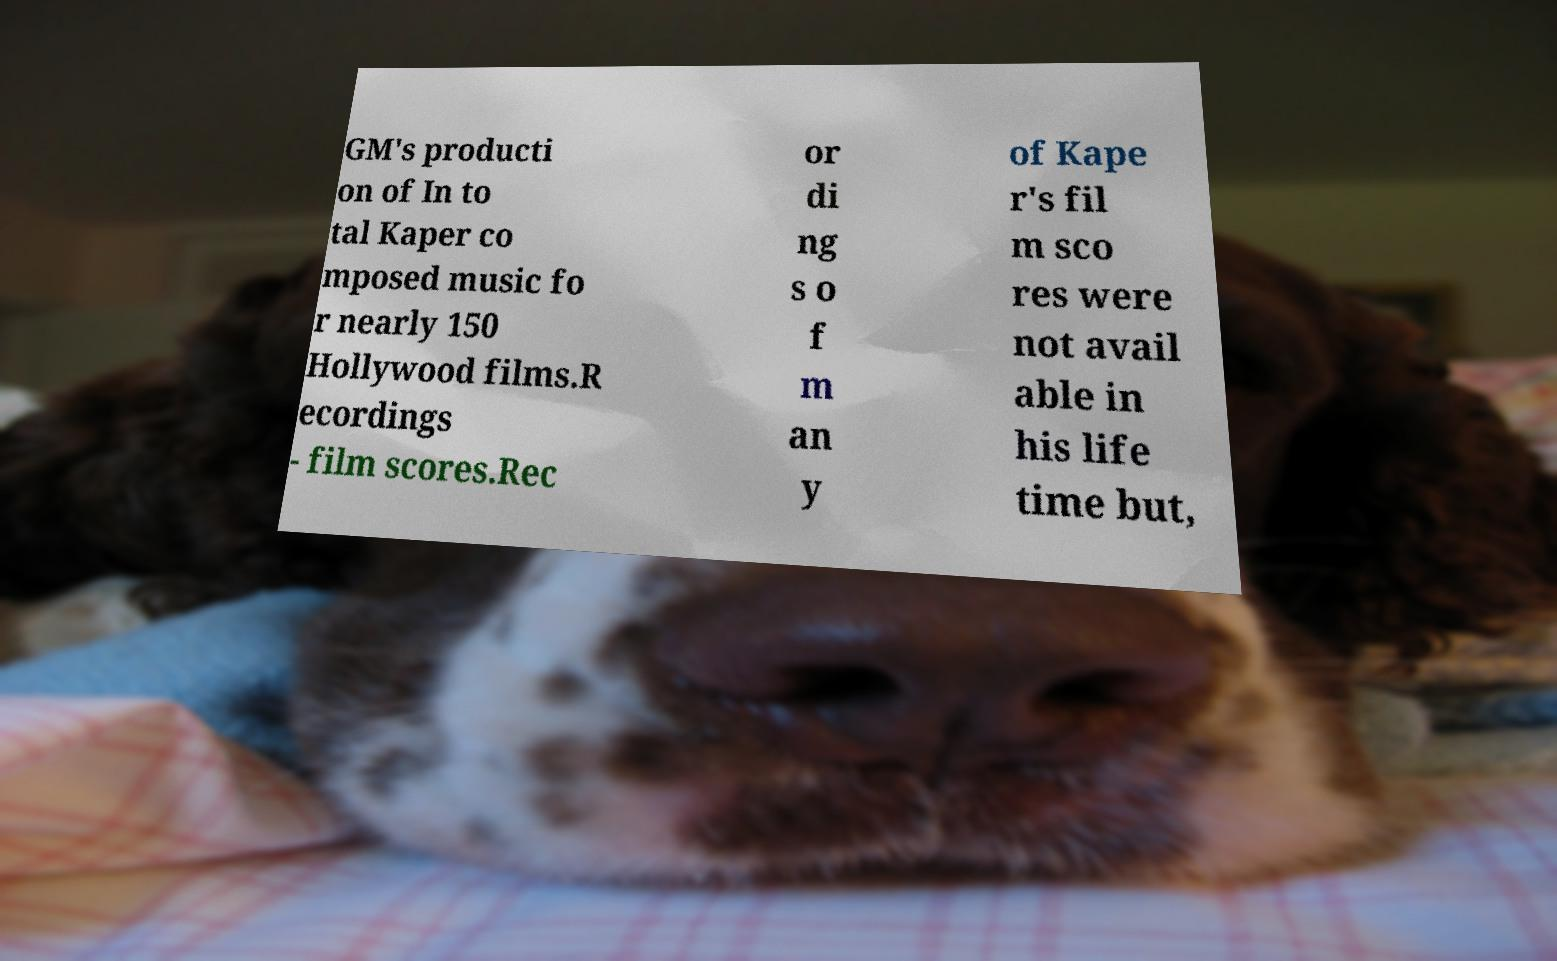Could you extract and type out the text from this image? GM's producti on of In to tal Kaper co mposed music fo r nearly 150 Hollywood films.R ecordings - film scores.Rec or di ng s o f m an y of Kape r's fil m sco res were not avail able in his life time but, 